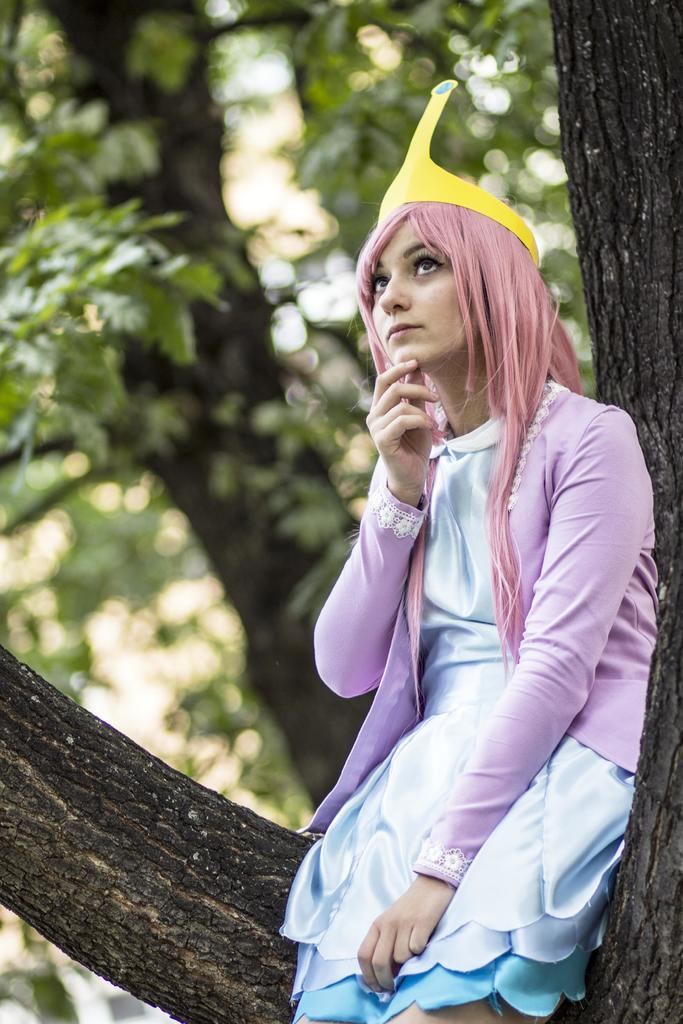Who is the main subject in the image? There is a girl in the image. What is the girl doing in the image? The girl is sitting on a tree. What is the girl wearing on her head? The girl is wearing a yellow cap. What color is the girl's top? The girl is wearing a pink top. What can be seen in the background of the image? There is a tree with green leaves in the background of the image. What type of health advice is the girl giving in the image? There is no indication in the image that the girl is giving any health advice. Is the girl holding a hammer in the image? No, the girl is not holding a hammer in the image. 